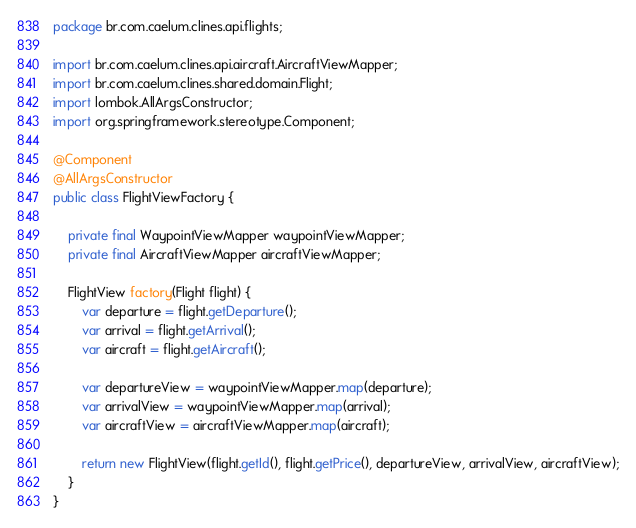Convert code to text. <code><loc_0><loc_0><loc_500><loc_500><_Java_>package br.com.caelum.clines.api.flights;

import br.com.caelum.clines.api.aircraft.AircraftViewMapper;
import br.com.caelum.clines.shared.domain.Flight;
import lombok.AllArgsConstructor;
import org.springframework.stereotype.Component;

@Component
@AllArgsConstructor
public class FlightViewFactory {

    private final WaypointViewMapper waypointViewMapper;
    private final AircraftViewMapper aircraftViewMapper;

    FlightView factory(Flight flight) {
        var departure = flight.getDeparture();
        var arrival = flight.getArrival();
        var aircraft = flight.getAircraft();

        var departureView = waypointViewMapper.map(departure);
        var arrivalView = waypointViewMapper.map(arrival);
        var aircraftView = aircraftViewMapper.map(aircraft);

        return new FlightView(flight.getId(), flight.getPrice(), departureView, arrivalView, aircraftView);
    }
}
</code> 